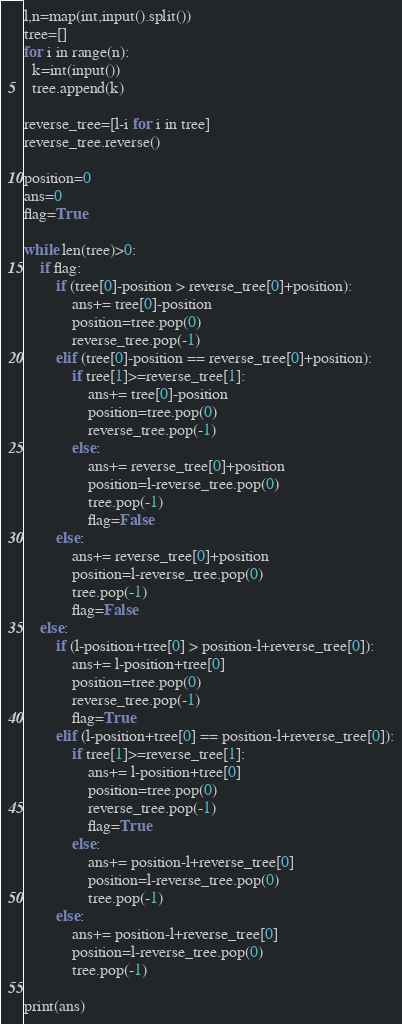Convert code to text. <code><loc_0><loc_0><loc_500><loc_500><_Python_>l,n=map(int,input().split())
tree=[]
for i in range(n):
  k=int(input())
  tree.append(k)

reverse_tree=[l-i for i in tree]
reverse_tree.reverse()

position=0
ans=0
flag=True

while len(tree)>0:
    if flag:
        if (tree[0]-position > reverse_tree[0]+position):
            ans+= tree[0]-position
            position=tree.pop(0)
            reverse_tree.pop(-1)
        elif (tree[0]-position == reverse_tree[0]+position):
            if tree[1]>=reverse_tree[1]:
                ans+= tree[0]-position
                position=tree.pop(0)
                reverse_tree.pop(-1)
            else:
                ans+= reverse_tree[0]+position
                position=l-reverse_tree.pop(0)
                tree.pop(-1)
                flag=False
        else:
            ans+= reverse_tree[0]+position
            position=l-reverse_tree.pop(0)
            tree.pop(-1)
            flag=False
    else:
        if (l-position+tree[0] > position-l+reverse_tree[0]):
            ans+= l-position+tree[0]
            position=tree.pop(0)
            reverse_tree.pop(-1)
            flag=True
        elif (l-position+tree[0] == position-l+reverse_tree[0]):
            if tree[1]>=reverse_tree[1]:
                ans+= l-position+tree[0]
                position=tree.pop(0)
                reverse_tree.pop(-1)
                flag=True
            else:
                ans+= position-l+reverse_tree[0]
                position=l-reverse_tree.pop(0)
                tree.pop(-1)
        else:
            ans+= position-l+reverse_tree[0]
            position=l-reverse_tree.pop(0)
            tree.pop(-1)

print(ans)
</code> 